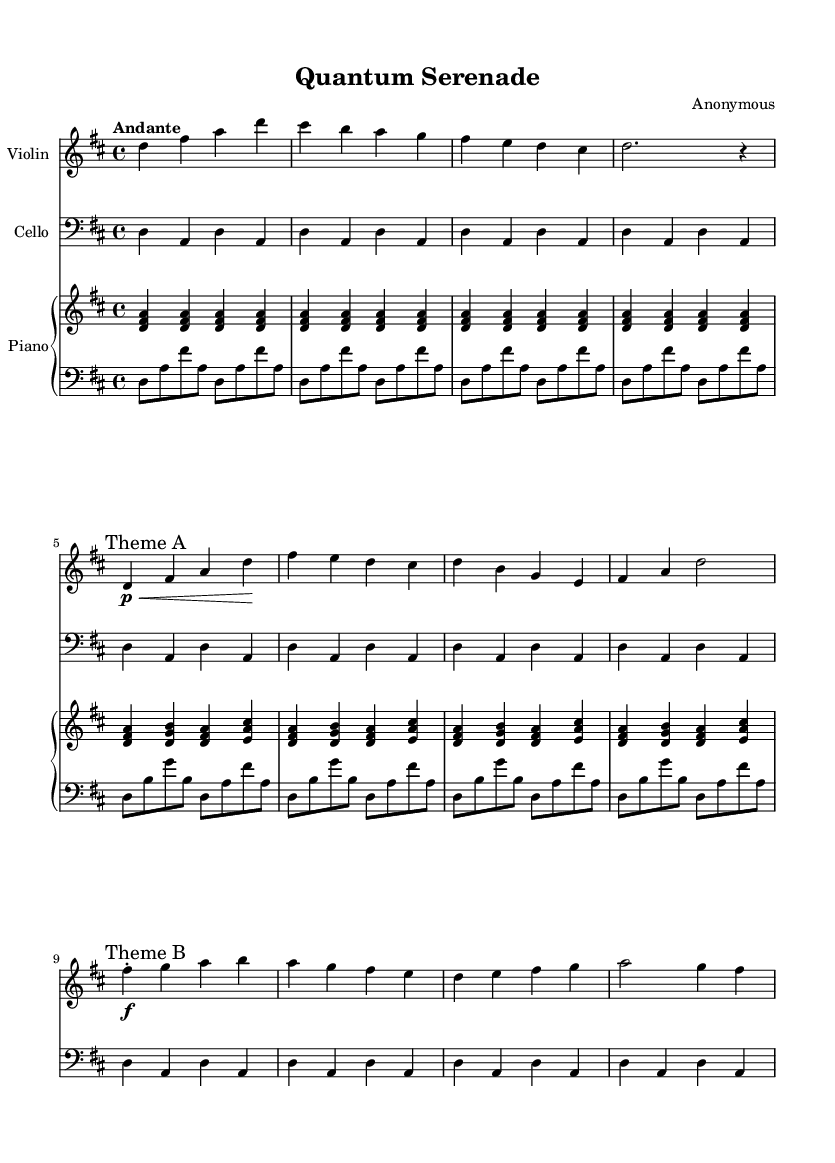What is the key signature of this music? The key signature is D major, indicated by two sharps on the staff.
Answer: D major What is the time signature of this piece? The time signature is 4/4, shown at the beginning of the score.
Answer: 4/4 What is the tempo marking for this composition? The tempo marking states "Andante," which indicates a moderate pace.
Answer: Andante How many distinct themes are presented in this piece? There are two distinct themes identified as "Theme A" and "Theme B."
Answer: Two What is the primary instrument used in the upper staff? The upper staff is designated for the piano, which is the primary instrument in this section.
Answer: Piano Which musical form can be inferred from the structure of the piece? The piece follows a binary form given the inclusion of two distinct themes.
Answer: Binary What emotion do the musical dynamics primarily convey throughout the piece? The dynamics alternate between piano and forte, suggesting a contrast between softness and intensity, signifying romantic expression.
Answer: Romantic expression 